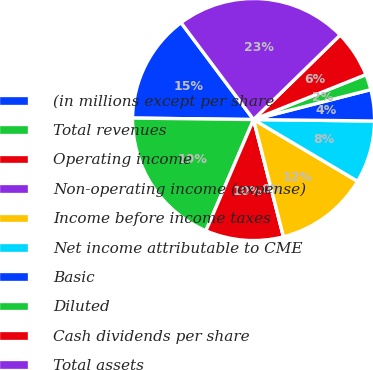Convert chart to OTSL. <chart><loc_0><loc_0><loc_500><loc_500><pie_chart><fcel>(in millions except per share<fcel>Total revenues<fcel>Operating income<fcel>Non-operating income (expense)<fcel>Income before income taxes<fcel>Net income attributable to CME<fcel>Basic<fcel>Diluted<fcel>Cash dividends per share<fcel>Total assets<nl><fcel>14.58%<fcel>18.75%<fcel>10.42%<fcel>0.0%<fcel>12.5%<fcel>8.33%<fcel>4.17%<fcel>2.08%<fcel>6.25%<fcel>22.92%<nl></chart> 